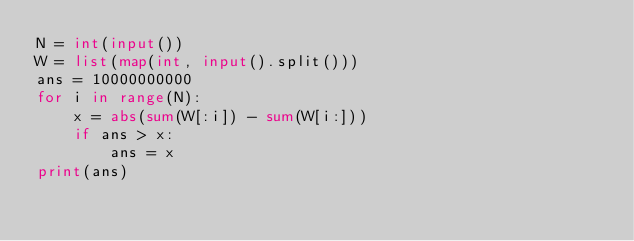Convert code to text. <code><loc_0><loc_0><loc_500><loc_500><_Python_>N = int(input())
W = list(map(int, input().split()))
ans = 10000000000
for i in range(N):
    x = abs(sum(W[:i]) - sum(W[i:])) 
    if ans > x:
        ans = x
print(ans)</code> 